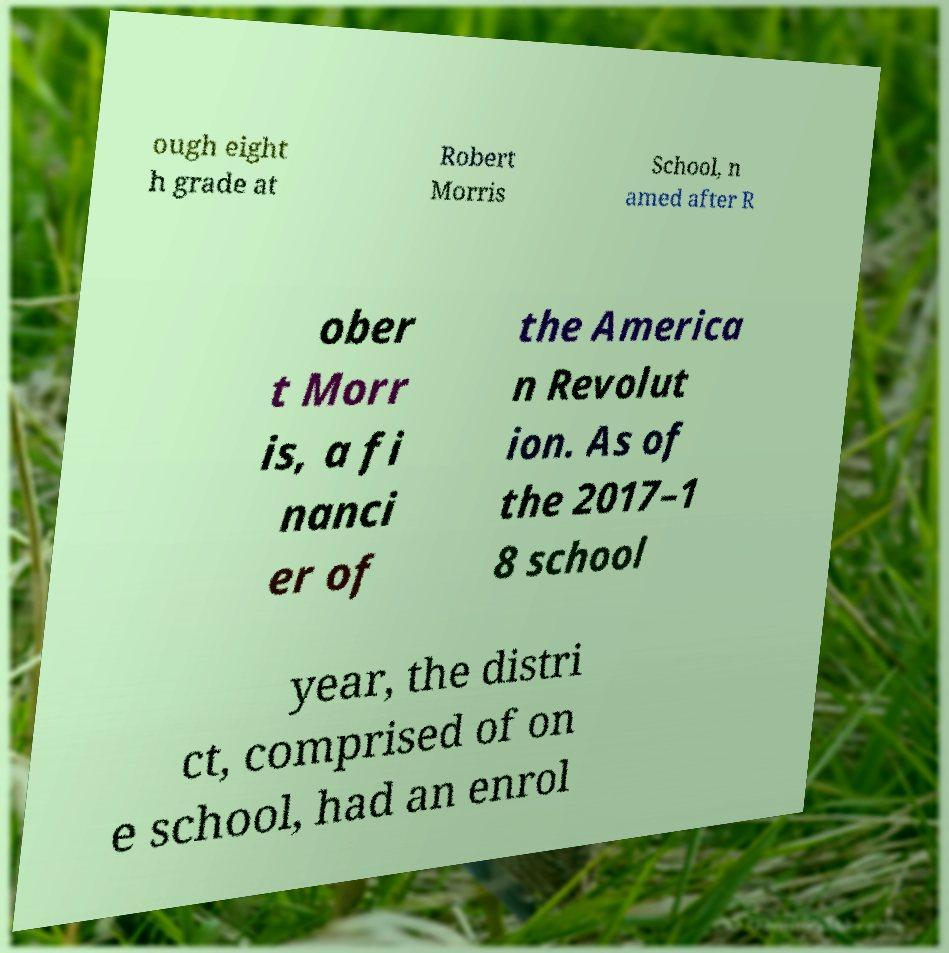There's text embedded in this image that I need extracted. Can you transcribe it verbatim? ough eight h grade at Robert Morris School, n amed after R ober t Morr is, a fi nanci er of the America n Revolut ion. As of the 2017–1 8 school year, the distri ct, comprised of on e school, had an enrol 